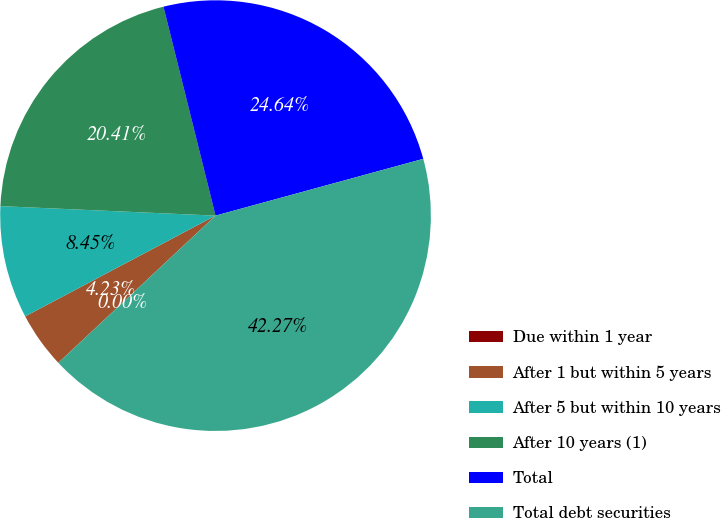<chart> <loc_0><loc_0><loc_500><loc_500><pie_chart><fcel>Due within 1 year<fcel>After 1 but within 5 years<fcel>After 5 but within 10 years<fcel>After 10 years (1)<fcel>Total<fcel>Total debt securities<nl><fcel>0.0%<fcel>4.23%<fcel>8.45%<fcel>20.41%<fcel>24.64%<fcel>42.27%<nl></chart> 